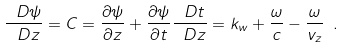Convert formula to latex. <formula><loc_0><loc_0><loc_500><loc_500>\frac { \ D \psi } { \ D z } = C = \frac { \partial \psi } { \partial z } + \frac { \partial \psi } { \partial t } \frac { \ D t } { \ D z } = k _ { w } + \frac { \omega } { c } - \frac { \omega } { v _ { z } } \ .</formula> 